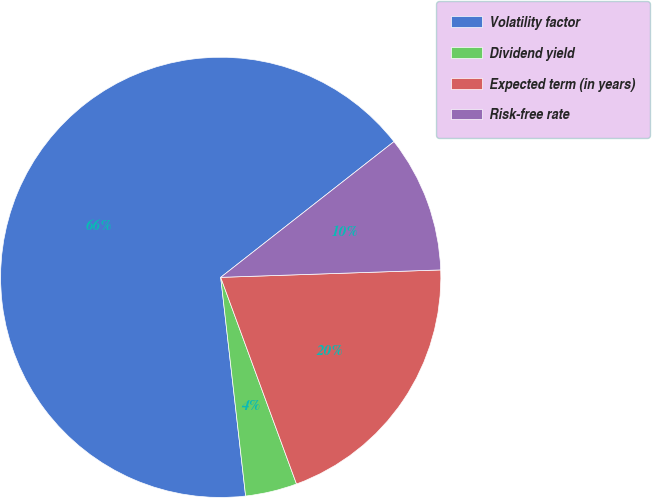Convert chart to OTSL. <chart><loc_0><loc_0><loc_500><loc_500><pie_chart><fcel>Volatility factor<fcel>Dividend yield<fcel>Expected term (in years)<fcel>Risk-free rate<nl><fcel>66.23%<fcel>3.79%<fcel>19.94%<fcel>10.04%<nl></chart> 